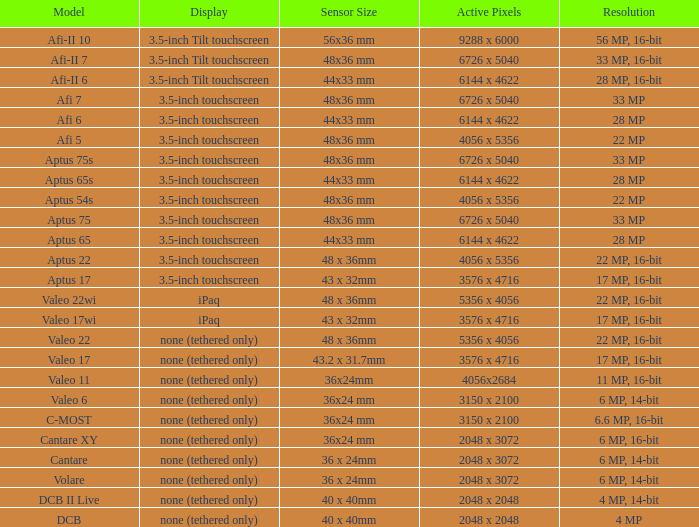What are the active pixels of the cantare model? 2048 x 3072. 